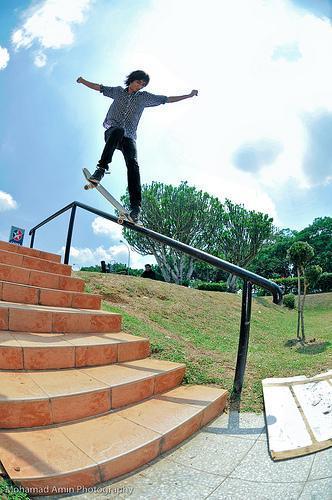How many people are riding skateboards?
Give a very brief answer. 1. 